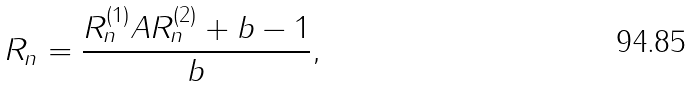<formula> <loc_0><loc_0><loc_500><loc_500>R _ { n } = \frac { R _ { n } ^ { ( 1 ) } A R _ { n } ^ { ( 2 ) } + b - 1 } { b } ,</formula> 